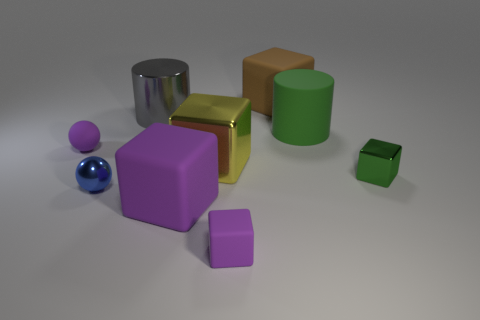Add 1 tiny shiny spheres. How many objects exist? 10 Subtract all yellow cubes. How many cubes are left? 4 Subtract all blue balls. How many purple blocks are left? 2 Subtract 2 cubes. How many cubes are left? 3 Subtract all yellow cubes. How many cubes are left? 4 Subtract all blocks. How many objects are left? 4 Add 7 tiny purple rubber balls. How many tiny purple rubber balls are left? 8 Add 7 tiny green metal balls. How many tiny green metal balls exist? 7 Subtract 2 purple blocks. How many objects are left? 7 Subtract all blue cylinders. Subtract all red blocks. How many cylinders are left? 2 